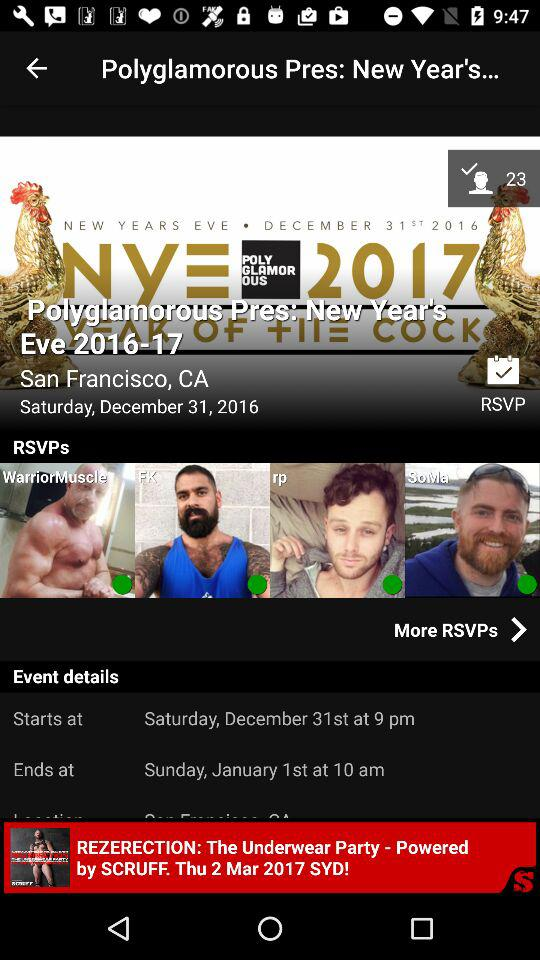At what time did the event start and end? The event started on Saturday, December 31st, at 9 pm and ended on Sunday, January 1st, at 10 am. 